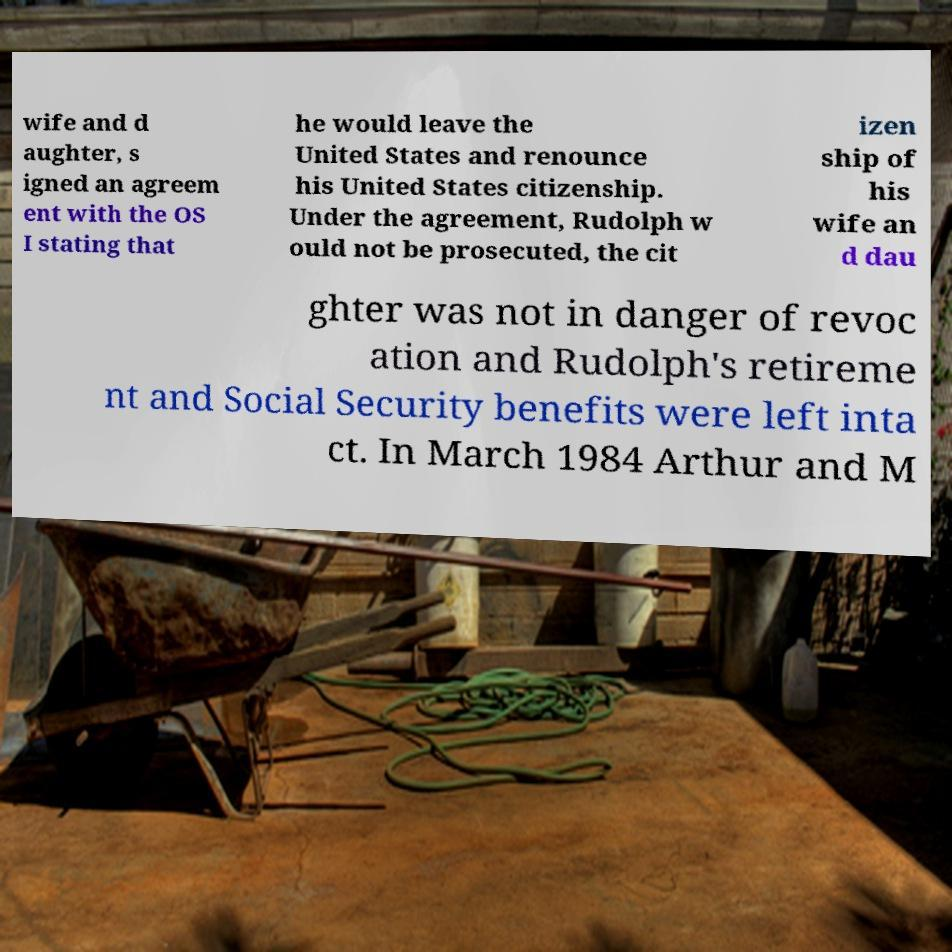What messages or text are displayed in this image? I need them in a readable, typed format. wife and d aughter, s igned an agreem ent with the OS I stating that he would leave the United States and renounce his United States citizenship. Under the agreement, Rudolph w ould not be prosecuted, the cit izen ship of his wife an d dau ghter was not in danger of revoc ation and Rudolph's retireme nt and Social Security benefits were left inta ct. In March 1984 Arthur and M 